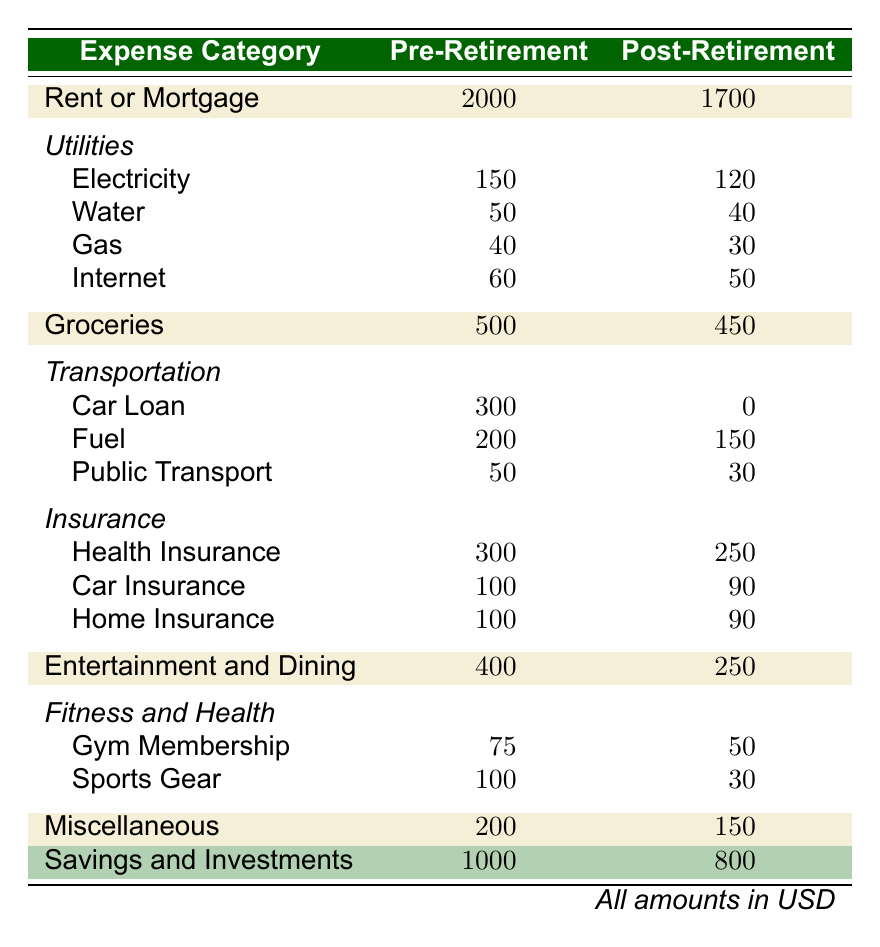What was the total expense on Utilities before retirement? We add up the individual expenses listed under Utilities: Electricity (150) + Water (50) + Gas (40) + Internet (60) = 300.
Answer: 300 How much did the individual spend on Groceries post-retirement? The table shows the amount spent on Groceries after retirement directly listed as 450.
Answer: 450 Was there any Car Loan payment in the post-retirement expenses? By looking at the table, the Car Loan expense is listed as 0 under Post-Retirement, indicating no payment is made.
Answer: No What is the difference in spending on Entertainment and Dining pre and post-retirement? The spending on Entertainment and Dining pre-retirement is 400, and post-retirement it's 250. Subtracting these values, 400 - 250 = 150 shows the difference.
Answer: 150 What is the total spent on Fitness and Health before retirement? To find this, we sum the expenses under Fitness and Health: Gym Membership (75) + Sports Gear (100) = 175.
Answer: 175 Are the total Savings and Investments higher pre-retirement compared to post-retirement? The table shows Savings and Investments as 1000 pre-retirement and 800 post-retirement, indicating that pre-retirement savings are higher.
Answer: Yes What was the percentage decrease in the Rent or Mortgage expense after retirement? The pre-retirement rent is 2000 and post-retirement it’s 1700. The decrease is 2000 - 1700 = 300, and the percentage decrease is (300/2000) * 100 = 15%.
Answer: 15% What category had the highest expense pre-retirement? Looking through the expense categories, Rent or Mortgage at 2000 is the highest listed value among all categories in pre-retirement.
Answer: Rent or Mortgage What is the total expenditure on Insurance post-retirement? We add the individual insurance expenses listed: Health Insurance (250) + Car Insurance (90) + Home Insurance (90) = 430.
Answer: 430 What is the total amount spent on Transportation pre-retirement? The total expenditure on Transportation includes Car Loan (300) + Fuel (200) + Public Transport (50) = 550.
Answer: 550 